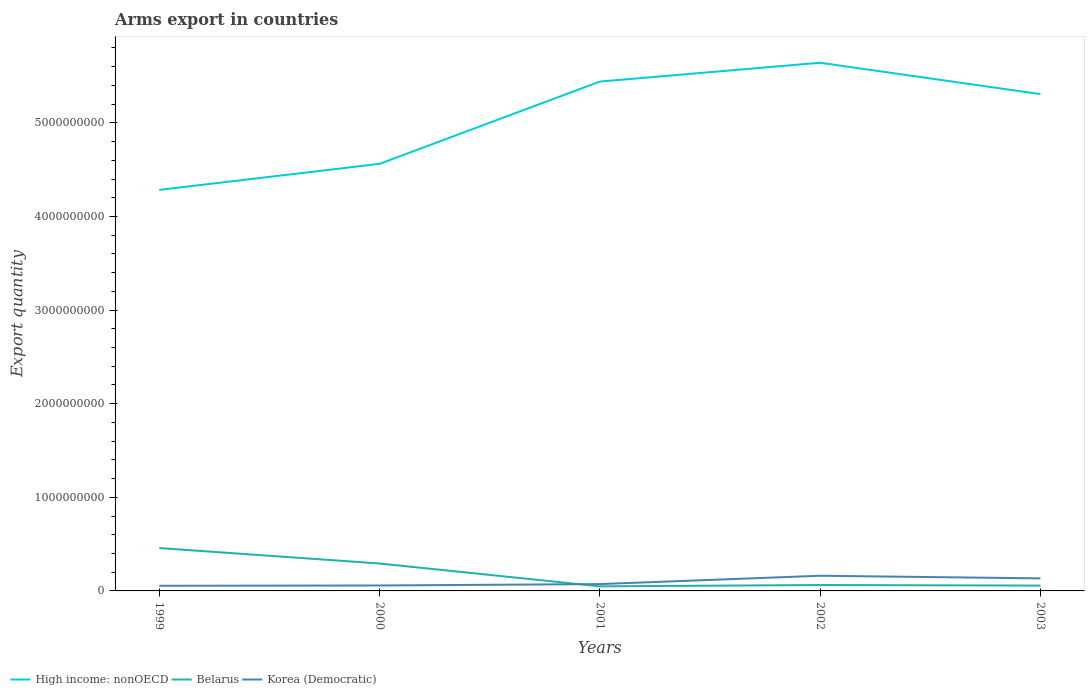Does the line corresponding to Belarus intersect with the line corresponding to Korea (Democratic)?
Keep it short and to the point. Yes. Across all years, what is the maximum total arms export in High income: nonOECD?
Ensure brevity in your answer.  4.28e+09. In which year was the total arms export in Korea (Democratic) maximum?
Keep it short and to the point. 1999. What is the total total arms export in Belarus in the graph?
Your response must be concise. 4.09e+08. What is the difference between the highest and the second highest total arms export in High income: nonOECD?
Your answer should be compact. 1.36e+09. What is the difference between the highest and the lowest total arms export in High income: nonOECD?
Provide a short and direct response. 3. Are the values on the major ticks of Y-axis written in scientific E-notation?
Make the answer very short. No. Does the graph contain any zero values?
Your response must be concise. No. Does the graph contain grids?
Your answer should be compact. No. How many legend labels are there?
Keep it short and to the point. 3. How are the legend labels stacked?
Keep it short and to the point. Horizontal. What is the title of the graph?
Your answer should be compact. Arms export in countries. What is the label or title of the X-axis?
Your response must be concise. Years. What is the label or title of the Y-axis?
Give a very brief answer. Export quantity. What is the Export quantity of High income: nonOECD in 1999?
Your answer should be compact. 4.28e+09. What is the Export quantity in Belarus in 1999?
Provide a succinct answer. 4.58e+08. What is the Export quantity of Korea (Democratic) in 1999?
Make the answer very short. 5.50e+07. What is the Export quantity of High income: nonOECD in 2000?
Make the answer very short. 4.56e+09. What is the Export quantity of Belarus in 2000?
Your response must be concise. 2.93e+08. What is the Export quantity of Korea (Democratic) in 2000?
Your answer should be very brief. 5.80e+07. What is the Export quantity of High income: nonOECD in 2001?
Keep it short and to the point. 5.44e+09. What is the Export quantity in Belarus in 2001?
Give a very brief answer. 4.90e+07. What is the Export quantity in Korea (Democratic) in 2001?
Your answer should be very brief. 7.30e+07. What is the Export quantity in High income: nonOECD in 2002?
Give a very brief answer. 5.64e+09. What is the Export quantity in Belarus in 2002?
Provide a short and direct response. 6.30e+07. What is the Export quantity in Korea (Democratic) in 2002?
Your response must be concise. 1.62e+08. What is the Export quantity of High income: nonOECD in 2003?
Keep it short and to the point. 5.31e+09. What is the Export quantity of Belarus in 2003?
Ensure brevity in your answer.  5.70e+07. What is the Export quantity of Korea (Democratic) in 2003?
Your answer should be very brief. 1.34e+08. Across all years, what is the maximum Export quantity of High income: nonOECD?
Offer a terse response. 5.64e+09. Across all years, what is the maximum Export quantity in Belarus?
Provide a succinct answer. 4.58e+08. Across all years, what is the maximum Export quantity in Korea (Democratic)?
Your response must be concise. 1.62e+08. Across all years, what is the minimum Export quantity in High income: nonOECD?
Ensure brevity in your answer.  4.28e+09. Across all years, what is the minimum Export quantity in Belarus?
Ensure brevity in your answer.  4.90e+07. Across all years, what is the minimum Export quantity in Korea (Democratic)?
Provide a short and direct response. 5.50e+07. What is the total Export quantity of High income: nonOECD in the graph?
Keep it short and to the point. 2.52e+1. What is the total Export quantity of Belarus in the graph?
Keep it short and to the point. 9.20e+08. What is the total Export quantity in Korea (Democratic) in the graph?
Your answer should be very brief. 4.82e+08. What is the difference between the Export quantity of High income: nonOECD in 1999 and that in 2000?
Offer a terse response. -2.78e+08. What is the difference between the Export quantity in Belarus in 1999 and that in 2000?
Your response must be concise. 1.65e+08. What is the difference between the Export quantity in High income: nonOECD in 1999 and that in 2001?
Provide a short and direct response. -1.16e+09. What is the difference between the Export quantity of Belarus in 1999 and that in 2001?
Your answer should be very brief. 4.09e+08. What is the difference between the Export quantity of Korea (Democratic) in 1999 and that in 2001?
Your response must be concise. -1.80e+07. What is the difference between the Export quantity of High income: nonOECD in 1999 and that in 2002?
Your response must be concise. -1.36e+09. What is the difference between the Export quantity of Belarus in 1999 and that in 2002?
Make the answer very short. 3.95e+08. What is the difference between the Export quantity in Korea (Democratic) in 1999 and that in 2002?
Provide a short and direct response. -1.07e+08. What is the difference between the Export quantity in High income: nonOECD in 1999 and that in 2003?
Your answer should be compact. -1.02e+09. What is the difference between the Export quantity in Belarus in 1999 and that in 2003?
Offer a very short reply. 4.01e+08. What is the difference between the Export quantity of Korea (Democratic) in 1999 and that in 2003?
Offer a very short reply. -7.90e+07. What is the difference between the Export quantity of High income: nonOECD in 2000 and that in 2001?
Your answer should be compact. -8.79e+08. What is the difference between the Export quantity in Belarus in 2000 and that in 2001?
Keep it short and to the point. 2.44e+08. What is the difference between the Export quantity of Korea (Democratic) in 2000 and that in 2001?
Keep it short and to the point. -1.50e+07. What is the difference between the Export quantity in High income: nonOECD in 2000 and that in 2002?
Keep it short and to the point. -1.08e+09. What is the difference between the Export quantity of Belarus in 2000 and that in 2002?
Offer a terse response. 2.30e+08. What is the difference between the Export quantity of Korea (Democratic) in 2000 and that in 2002?
Your answer should be compact. -1.04e+08. What is the difference between the Export quantity of High income: nonOECD in 2000 and that in 2003?
Your answer should be compact. -7.45e+08. What is the difference between the Export quantity in Belarus in 2000 and that in 2003?
Make the answer very short. 2.36e+08. What is the difference between the Export quantity of Korea (Democratic) in 2000 and that in 2003?
Offer a very short reply. -7.60e+07. What is the difference between the Export quantity of High income: nonOECD in 2001 and that in 2002?
Offer a terse response. -2.01e+08. What is the difference between the Export quantity in Belarus in 2001 and that in 2002?
Provide a succinct answer. -1.40e+07. What is the difference between the Export quantity in Korea (Democratic) in 2001 and that in 2002?
Provide a succinct answer. -8.90e+07. What is the difference between the Export quantity of High income: nonOECD in 2001 and that in 2003?
Provide a succinct answer. 1.34e+08. What is the difference between the Export quantity in Belarus in 2001 and that in 2003?
Offer a very short reply. -8.00e+06. What is the difference between the Export quantity in Korea (Democratic) in 2001 and that in 2003?
Offer a very short reply. -6.10e+07. What is the difference between the Export quantity in High income: nonOECD in 2002 and that in 2003?
Provide a succinct answer. 3.35e+08. What is the difference between the Export quantity of Korea (Democratic) in 2002 and that in 2003?
Offer a terse response. 2.80e+07. What is the difference between the Export quantity of High income: nonOECD in 1999 and the Export quantity of Belarus in 2000?
Your response must be concise. 3.99e+09. What is the difference between the Export quantity in High income: nonOECD in 1999 and the Export quantity in Korea (Democratic) in 2000?
Provide a succinct answer. 4.23e+09. What is the difference between the Export quantity of Belarus in 1999 and the Export quantity of Korea (Democratic) in 2000?
Your response must be concise. 4.00e+08. What is the difference between the Export quantity of High income: nonOECD in 1999 and the Export quantity of Belarus in 2001?
Your answer should be very brief. 4.24e+09. What is the difference between the Export quantity in High income: nonOECD in 1999 and the Export quantity in Korea (Democratic) in 2001?
Keep it short and to the point. 4.21e+09. What is the difference between the Export quantity of Belarus in 1999 and the Export quantity of Korea (Democratic) in 2001?
Your response must be concise. 3.85e+08. What is the difference between the Export quantity in High income: nonOECD in 1999 and the Export quantity in Belarus in 2002?
Keep it short and to the point. 4.22e+09. What is the difference between the Export quantity of High income: nonOECD in 1999 and the Export quantity of Korea (Democratic) in 2002?
Give a very brief answer. 4.12e+09. What is the difference between the Export quantity in Belarus in 1999 and the Export quantity in Korea (Democratic) in 2002?
Offer a terse response. 2.96e+08. What is the difference between the Export quantity in High income: nonOECD in 1999 and the Export quantity in Belarus in 2003?
Keep it short and to the point. 4.23e+09. What is the difference between the Export quantity in High income: nonOECD in 1999 and the Export quantity in Korea (Democratic) in 2003?
Your answer should be compact. 4.15e+09. What is the difference between the Export quantity of Belarus in 1999 and the Export quantity of Korea (Democratic) in 2003?
Your answer should be compact. 3.24e+08. What is the difference between the Export quantity of High income: nonOECD in 2000 and the Export quantity of Belarus in 2001?
Keep it short and to the point. 4.51e+09. What is the difference between the Export quantity of High income: nonOECD in 2000 and the Export quantity of Korea (Democratic) in 2001?
Your answer should be compact. 4.49e+09. What is the difference between the Export quantity in Belarus in 2000 and the Export quantity in Korea (Democratic) in 2001?
Ensure brevity in your answer.  2.20e+08. What is the difference between the Export quantity of High income: nonOECD in 2000 and the Export quantity of Belarus in 2002?
Ensure brevity in your answer.  4.50e+09. What is the difference between the Export quantity of High income: nonOECD in 2000 and the Export quantity of Korea (Democratic) in 2002?
Your answer should be very brief. 4.40e+09. What is the difference between the Export quantity of Belarus in 2000 and the Export quantity of Korea (Democratic) in 2002?
Give a very brief answer. 1.31e+08. What is the difference between the Export quantity of High income: nonOECD in 2000 and the Export quantity of Belarus in 2003?
Make the answer very short. 4.50e+09. What is the difference between the Export quantity of High income: nonOECD in 2000 and the Export quantity of Korea (Democratic) in 2003?
Give a very brief answer. 4.43e+09. What is the difference between the Export quantity of Belarus in 2000 and the Export quantity of Korea (Democratic) in 2003?
Offer a terse response. 1.59e+08. What is the difference between the Export quantity in High income: nonOECD in 2001 and the Export quantity in Belarus in 2002?
Provide a short and direct response. 5.38e+09. What is the difference between the Export quantity in High income: nonOECD in 2001 and the Export quantity in Korea (Democratic) in 2002?
Provide a short and direct response. 5.28e+09. What is the difference between the Export quantity in Belarus in 2001 and the Export quantity in Korea (Democratic) in 2002?
Give a very brief answer. -1.13e+08. What is the difference between the Export quantity of High income: nonOECD in 2001 and the Export quantity of Belarus in 2003?
Give a very brief answer. 5.38e+09. What is the difference between the Export quantity of High income: nonOECD in 2001 and the Export quantity of Korea (Democratic) in 2003?
Provide a short and direct response. 5.31e+09. What is the difference between the Export quantity in Belarus in 2001 and the Export quantity in Korea (Democratic) in 2003?
Provide a succinct answer. -8.50e+07. What is the difference between the Export quantity of High income: nonOECD in 2002 and the Export quantity of Belarus in 2003?
Offer a very short reply. 5.58e+09. What is the difference between the Export quantity of High income: nonOECD in 2002 and the Export quantity of Korea (Democratic) in 2003?
Provide a short and direct response. 5.51e+09. What is the difference between the Export quantity in Belarus in 2002 and the Export quantity in Korea (Democratic) in 2003?
Offer a very short reply. -7.10e+07. What is the average Export quantity of High income: nonOECD per year?
Your answer should be very brief. 5.05e+09. What is the average Export quantity of Belarus per year?
Your response must be concise. 1.84e+08. What is the average Export quantity in Korea (Democratic) per year?
Your response must be concise. 9.64e+07. In the year 1999, what is the difference between the Export quantity of High income: nonOECD and Export quantity of Belarus?
Ensure brevity in your answer.  3.83e+09. In the year 1999, what is the difference between the Export quantity in High income: nonOECD and Export quantity in Korea (Democratic)?
Make the answer very short. 4.23e+09. In the year 1999, what is the difference between the Export quantity of Belarus and Export quantity of Korea (Democratic)?
Ensure brevity in your answer.  4.03e+08. In the year 2000, what is the difference between the Export quantity in High income: nonOECD and Export quantity in Belarus?
Your answer should be very brief. 4.27e+09. In the year 2000, what is the difference between the Export quantity in High income: nonOECD and Export quantity in Korea (Democratic)?
Your answer should be very brief. 4.50e+09. In the year 2000, what is the difference between the Export quantity in Belarus and Export quantity in Korea (Democratic)?
Provide a short and direct response. 2.35e+08. In the year 2001, what is the difference between the Export quantity of High income: nonOECD and Export quantity of Belarus?
Make the answer very short. 5.39e+09. In the year 2001, what is the difference between the Export quantity in High income: nonOECD and Export quantity in Korea (Democratic)?
Offer a very short reply. 5.37e+09. In the year 2001, what is the difference between the Export quantity in Belarus and Export quantity in Korea (Democratic)?
Give a very brief answer. -2.40e+07. In the year 2002, what is the difference between the Export quantity of High income: nonOECD and Export quantity of Belarus?
Your response must be concise. 5.58e+09. In the year 2002, what is the difference between the Export quantity of High income: nonOECD and Export quantity of Korea (Democratic)?
Make the answer very short. 5.48e+09. In the year 2002, what is the difference between the Export quantity of Belarus and Export quantity of Korea (Democratic)?
Your response must be concise. -9.90e+07. In the year 2003, what is the difference between the Export quantity of High income: nonOECD and Export quantity of Belarus?
Provide a short and direct response. 5.25e+09. In the year 2003, what is the difference between the Export quantity in High income: nonOECD and Export quantity in Korea (Democratic)?
Make the answer very short. 5.17e+09. In the year 2003, what is the difference between the Export quantity of Belarus and Export quantity of Korea (Democratic)?
Keep it short and to the point. -7.70e+07. What is the ratio of the Export quantity of High income: nonOECD in 1999 to that in 2000?
Ensure brevity in your answer.  0.94. What is the ratio of the Export quantity in Belarus in 1999 to that in 2000?
Give a very brief answer. 1.56. What is the ratio of the Export quantity in Korea (Democratic) in 1999 to that in 2000?
Make the answer very short. 0.95. What is the ratio of the Export quantity in High income: nonOECD in 1999 to that in 2001?
Your answer should be very brief. 0.79. What is the ratio of the Export quantity in Belarus in 1999 to that in 2001?
Give a very brief answer. 9.35. What is the ratio of the Export quantity of Korea (Democratic) in 1999 to that in 2001?
Give a very brief answer. 0.75. What is the ratio of the Export quantity in High income: nonOECD in 1999 to that in 2002?
Provide a succinct answer. 0.76. What is the ratio of the Export quantity in Belarus in 1999 to that in 2002?
Your answer should be compact. 7.27. What is the ratio of the Export quantity of Korea (Democratic) in 1999 to that in 2002?
Give a very brief answer. 0.34. What is the ratio of the Export quantity of High income: nonOECD in 1999 to that in 2003?
Offer a terse response. 0.81. What is the ratio of the Export quantity in Belarus in 1999 to that in 2003?
Give a very brief answer. 8.04. What is the ratio of the Export quantity in Korea (Democratic) in 1999 to that in 2003?
Provide a succinct answer. 0.41. What is the ratio of the Export quantity in High income: nonOECD in 2000 to that in 2001?
Offer a terse response. 0.84. What is the ratio of the Export quantity in Belarus in 2000 to that in 2001?
Make the answer very short. 5.98. What is the ratio of the Export quantity of Korea (Democratic) in 2000 to that in 2001?
Your answer should be compact. 0.79. What is the ratio of the Export quantity in High income: nonOECD in 2000 to that in 2002?
Your answer should be very brief. 0.81. What is the ratio of the Export quantity in Belarus in 2000 to that in 2002?
Provide a short and direct response. 4.65. What is the ratio of the Export quantity of Korea (Democratic) in 2000 to that in 2002?
Your response must be concise. 0.36. What is the ratio of the Export quantity of High income: nonOECD in 2000 to that in 2003?
Provide a succinct answer. 0.86. What is the ratio of the Export quantity of Belarus in 2000 to that in 2003?
Provide a short and direct response. 5.14. What is the ratio of the Export quantity of Korea (Democratic) in 2000 to that in 2003?
Offer a very short reply. 0.43. What is the ratio of the Export quantity in High income: nonOECD in 2001 to that in 2002?
Your answer should be very brief. 0.96. What is the ratio of the Export quantity in Belarus in 2001 to that in 2002?
Your response must be concise. 0.78. What is the ratio of the Export quantity of Korea (Democratic) in 2001 to that in 2002?
Offer a very short reply. 0.45. What is the ratio of the Export quantity of High income: nonOECD in 2001 to that in 2003?
Ensure brevity in your answer.  1.03. What is the ratio of the Export quantity in Belarus in 2001 to that in 2003?
Make the answer very short. 0.86. What is the ratio of the Export quantity in Korea (Democratic) in 2001 to that in 2003?
Your answer should be compact. 0.54. What is the ratio of the Export quantity in High income: nonOECD in 2002 to that in 2003?
Provide a succinct answer. 1.06. What is the ratio of the Export quantity of Belarus in 2002 to that in 2003?
Give a very brief answer. 1.11. What is the ratio of the Export quantity in Korea (Democratic) in 2002 to that in 2003?
Make the answer very short. 1.21. What is the difference between the highest and the second highest Export quantity in High income: nonOECD?
Your answer should be very brief. 2.01e+08. What is the difference between the highest and the second highest Export quantity of Belarus?
Keep it short and to the point. 1.65e+08. What is the difference between the highest and the second highest Export quantity of Korea (Democratic)?
Ensure brevity in your answer.  2.80e+07. What is the difference between the highest and the lowest Export quantity of High income: nonOECD?
Your answer should be compact. 1.36e+09. What is the difference between the highest and the lowest Export quantity in Belarus?
Provide a succinct answer. 4.09e+08. What is the difference between the highest and the lowest Export quantity in Korea (Democratic)?
Ensure brevity in your answer.  1.07e+08. 